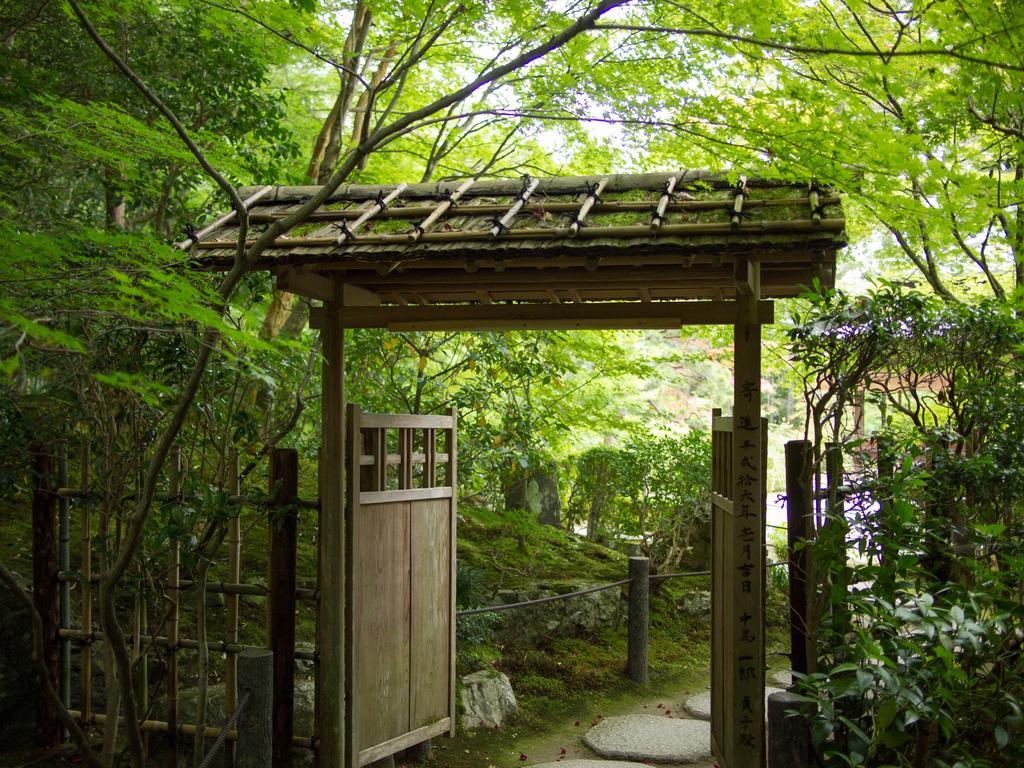Please provide a concise description of this image. In this picture, we can see an entrance with gate, trees, plants, ground, fencing and the sky. 